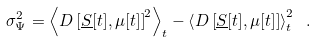<formula> <loc_0><loc_0><loc_500><loc_500>\sigma _ { \Psi } ^ { 2 } = \left \langle D \left [ \underline { S } [ t ] , \mu [ t ] \right ] ^ { 2 } \right \rangle _ { t } - \left \langle D \left [ \underline { S } [ t ] , \mu [ t ] \right ] \right \rangle _ { t } ^ { 2 } \ .</formula> 